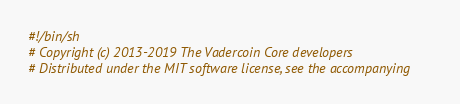Convert code to text. <code><loc_0><loc_0><loc_500><loc_500><_Bash_>#!/bin/sh
# Copyright (c) 2013-2019 The Vadercoin Core developers
# Distributed under the MIT software license, see the accompanying</code> 